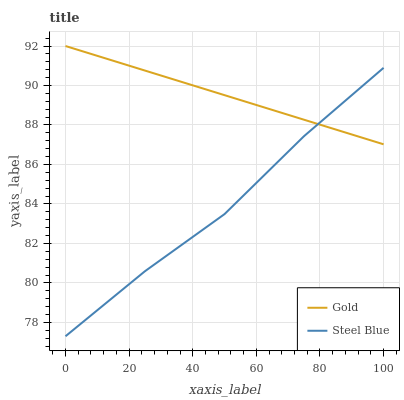Does Steel Blue have the minimum area under the curve?
Answer yes or no. Yes. Does Gold have the maximum area under the curve?
Answer yes or no. Yes. Does Gold have the minimum area under the curve?
Answer yes or no. No. Is Gold the smoothest?
Answer yes or no. Yes. Is Steel Blue the roughest?
Answer yes or no. Yes. Is Gold the roughest?
Answer yes or no. No. Does Steel Blue have the lowest value?
Answer yes or no. Yes. Does Gold have the lowest value?
Answer yes or no. No. Does Gold have the highest value?
Answer yes or no. Yes. Does Gold intersect Steel Blue?
Answer yes or no. Yes. Is Gold less than Steel Blue?
Answer yes or no. No. Is Gold greater than Steel Blue?
Answer yes or no. No. 